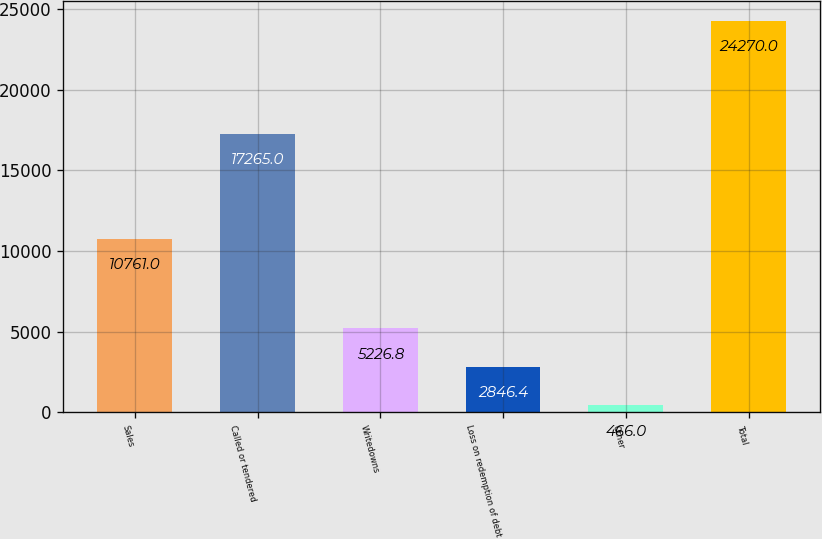<chart> <loc_0><loc_0><loc_500><loc_500><bar_chart><fcel>Sales<fcel>Called or tendered<fcel>Writedowns<fcel>Loss on redemption of debt<fcel>Other<fcel>Total<nl><fcel>10761<fcel>17265<fcel>5226.8<fcel>2846.4<fcel>466<fcel>24270<nl></chart> 